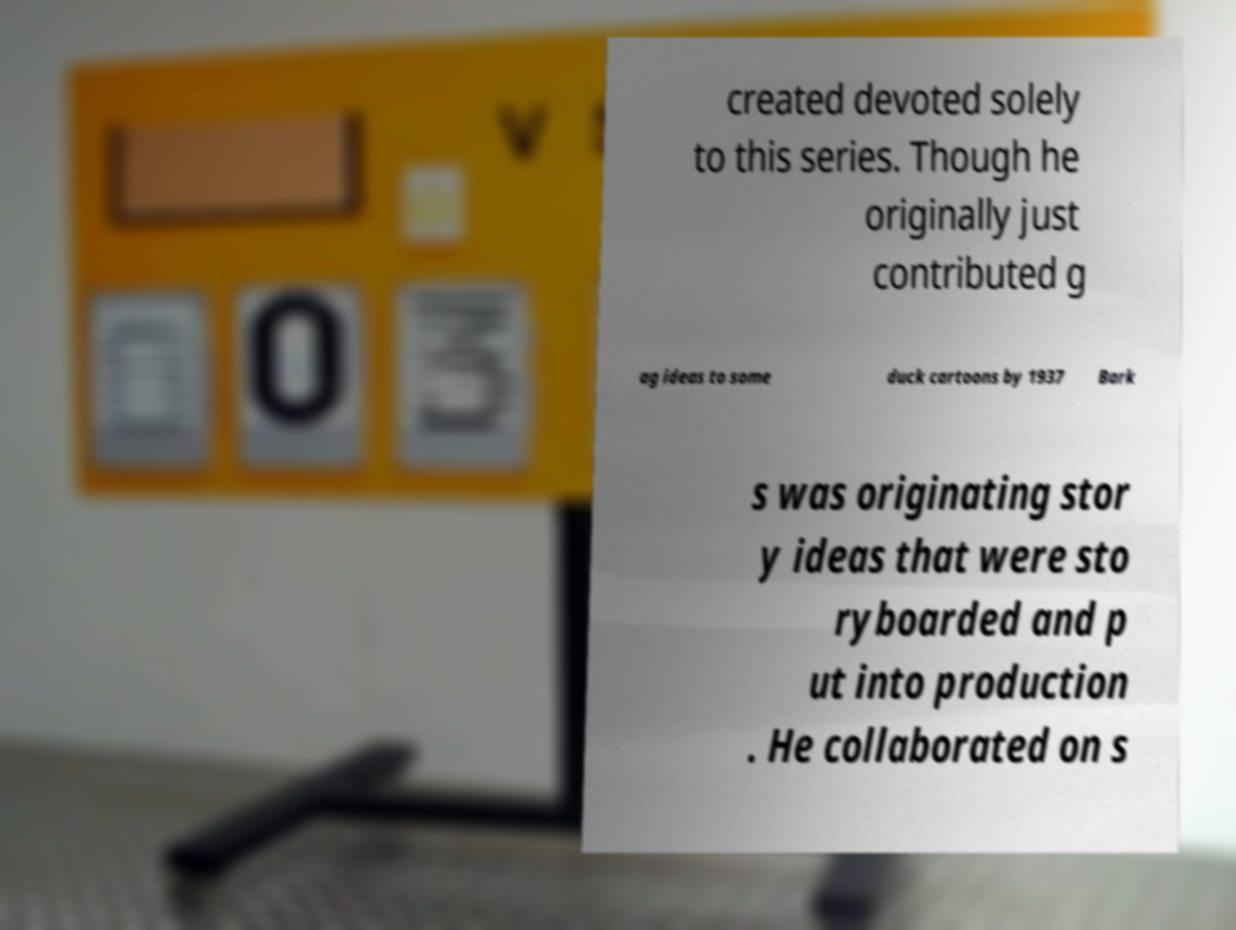There's text embedded in this image that I need extracted. Can you transcribe it verbatim? created devoted solely to this series. Though he originally just contributed g ag ideas to some duck cartoons by 1937 Bark s was originating stor y ideas that were sto ryboarded and p ut into production . He collaborated on s 